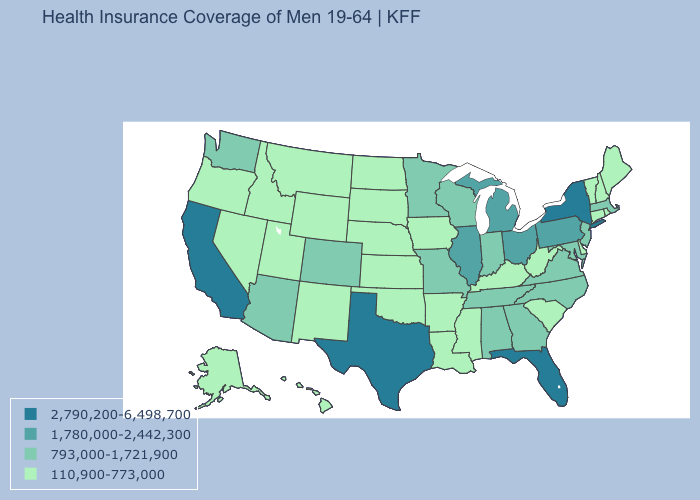Is the legend a continuous bar?
Quick response, please. No. Does Rhode Island have a lower value than Massachusetts?
Give a very brief answer. Yes. Name the states that have a value in the range 110,900-773,000?
Answer briefly. Alaska, Arkansas, Connecticut, Delaware, Hawaii, Idaho, Iowa, Kansas, Kentucky, Louisiana, Maine, Mississippi, Montana, Nebraska, Nevada, New Hampshire, New Mexico, North Dakota, Oklahoma, Oregon, Rhode Island, South Carolina, South Dakota, Utah, Vermont, West Virginia, Wyoming. Name the states that have a value in the range 1,780,000-2,442,300?
Quick response, please. Illinois, Michigan, Ohio, Pennsylvania. Does North Dakota have a lower value than Hawaii?
Concise answer only. No. Name the states that have a value in the range 110,900-773,000?
Keep it brief. Alaska, Arkansas, Connecticut, Delaware, Hawaii, Idaho, Iowa, Kansas, Kentucky, Louisiana, Maine, Mississippi, Montana, Nebraska, Nevada, New Hampshire, New Mexico, North Dakota, Oklahoma, Oregon, Rhode Island, South Carolina, South Dakota, Utah, Vermont, West Virginia, Wyoming. What is the highest value in the MidWest ?
Answer briefly. 1,780,000-2,442,300. What is the value of Iowa?
Keep it brief. 110,900-773,000. Name the states that have a value in the range 2,790,200-6,498,700?
Concise answer only. California, Florida, New York, Texas. What is the value of Alaska?
Give a very brief answer. 110,900-773,000. What is the highest value in states that border Kentucky?
Concise answer only. 1,780,000-2,442,300. Does the first symbol in the legend represent the smallest category?
Answer briefly. No. Among the states that border New Jersey , does Pennsylvania have the highest value?
Write a very short answer. No. Does Maryland have a lower value than Delaware?
Write a very short answer. No. Among the states that border New Jersey , which have the highest value?
Write a very short answer. New York. 